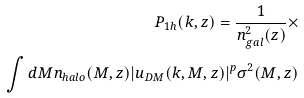<formula> <loc_0><loc_0><loc_500><loc_500>P _ { 1 h } ( k , z ) = \frac { 1 } { n ^ { 2 } _ { g a l } ( z ) } \times \\ \int d M n _ { h a l o } ( M , z ) | u _ { D M } ( k , M , z ) | ^ { p } \sigma ^ { 2 } ( M , z )</formula> 